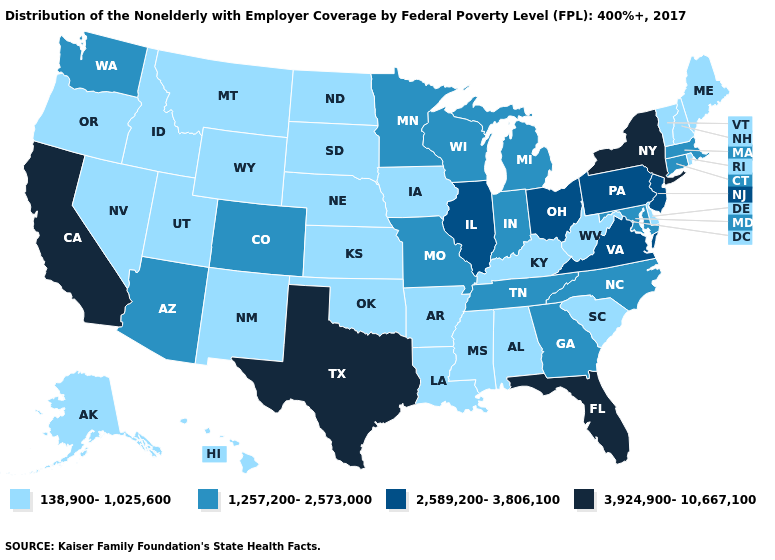What is the value of Indiana?
Be succinct. 1,257,200-2,573,000. What is the value of California?
Answer briefly. 3,924,900-10,667,100. Which states have the highest value in the USA?
Keep it brief. California, Florida, New York, Texas. What is the lowest value in states that border Vermont?
Be succinct. 138,900-1,025,600. Among the states that border Pennsylvania , which have the highest value?
Answer briefly. New York. What is the highest value in states that border New Hampshire?
Short answer required. 1,257,200-2,573,000. Does the first symbol in the legend represent the smallest category?
Give a very brief answer. Yes. Which states have the highest value in the USA?
Answer briefly. California, Florida, New York, Texas. How many symbols are there in the legend?
Quick response, please. 4. Name the states that have a value in the range 2,589,200-3,806,100?
Answer briefly. Illinois, New Jersey, Ohio, Pennsylvania, Virginia. Name the states that have a value in the range 1,257,200-2,573,000?
Quick response, please. Arizona, Colorado, Connecticut, Georgia, Indiana, Maryland, Massachusetts, Michigan, Minnesota, Missouri, North Carolina, Tennessee, Washington, Wisconsin. What is the value of California?
Short answer required. 3,924,900-10,667,100. What is the value of Nevada?
Answer briefly. 138,900-1,025,600. Does New York have the highest value in the USA?
Quick response, please. Yes. Does New York have the highest value in the Northeast?
Answer briefly. Yes. 